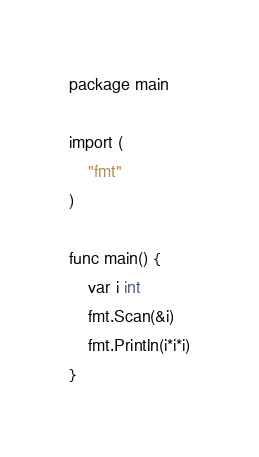<code> <loc_0><loc_0><loc_500><loc_500><_Go_>package main

import (
	"fmt"
)

func main() {
	var i int
	fmt.Scan(&i)
	fmt.Println(i*i*i)
}

</code> 